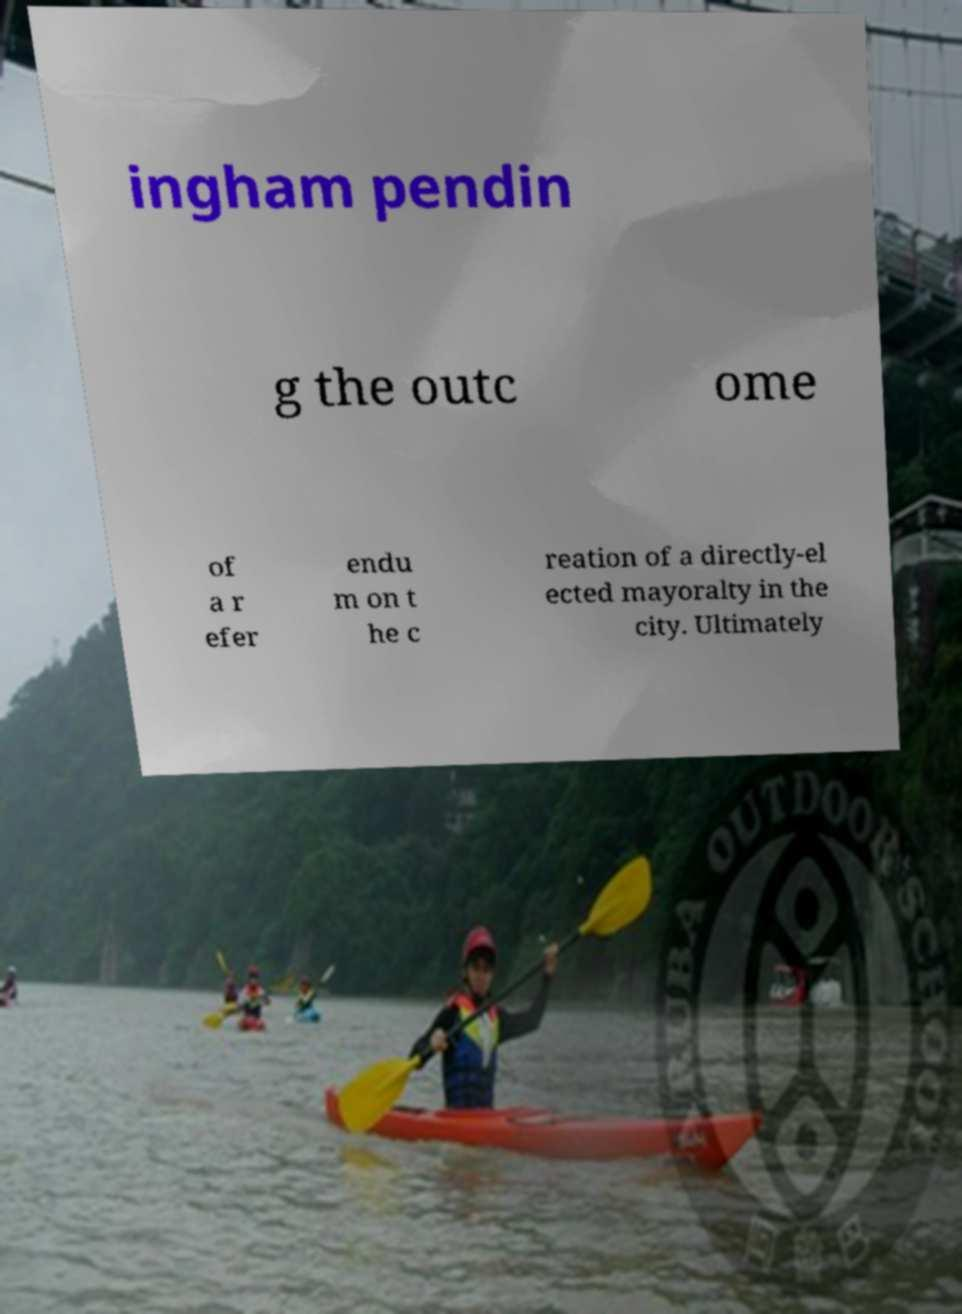Please read and relay the text visible in this image. What does it say? ingham pendin g the outc ome of a r efer endu m on t he c reation of a directly-el ected mayoralty in the city. Ultimately 